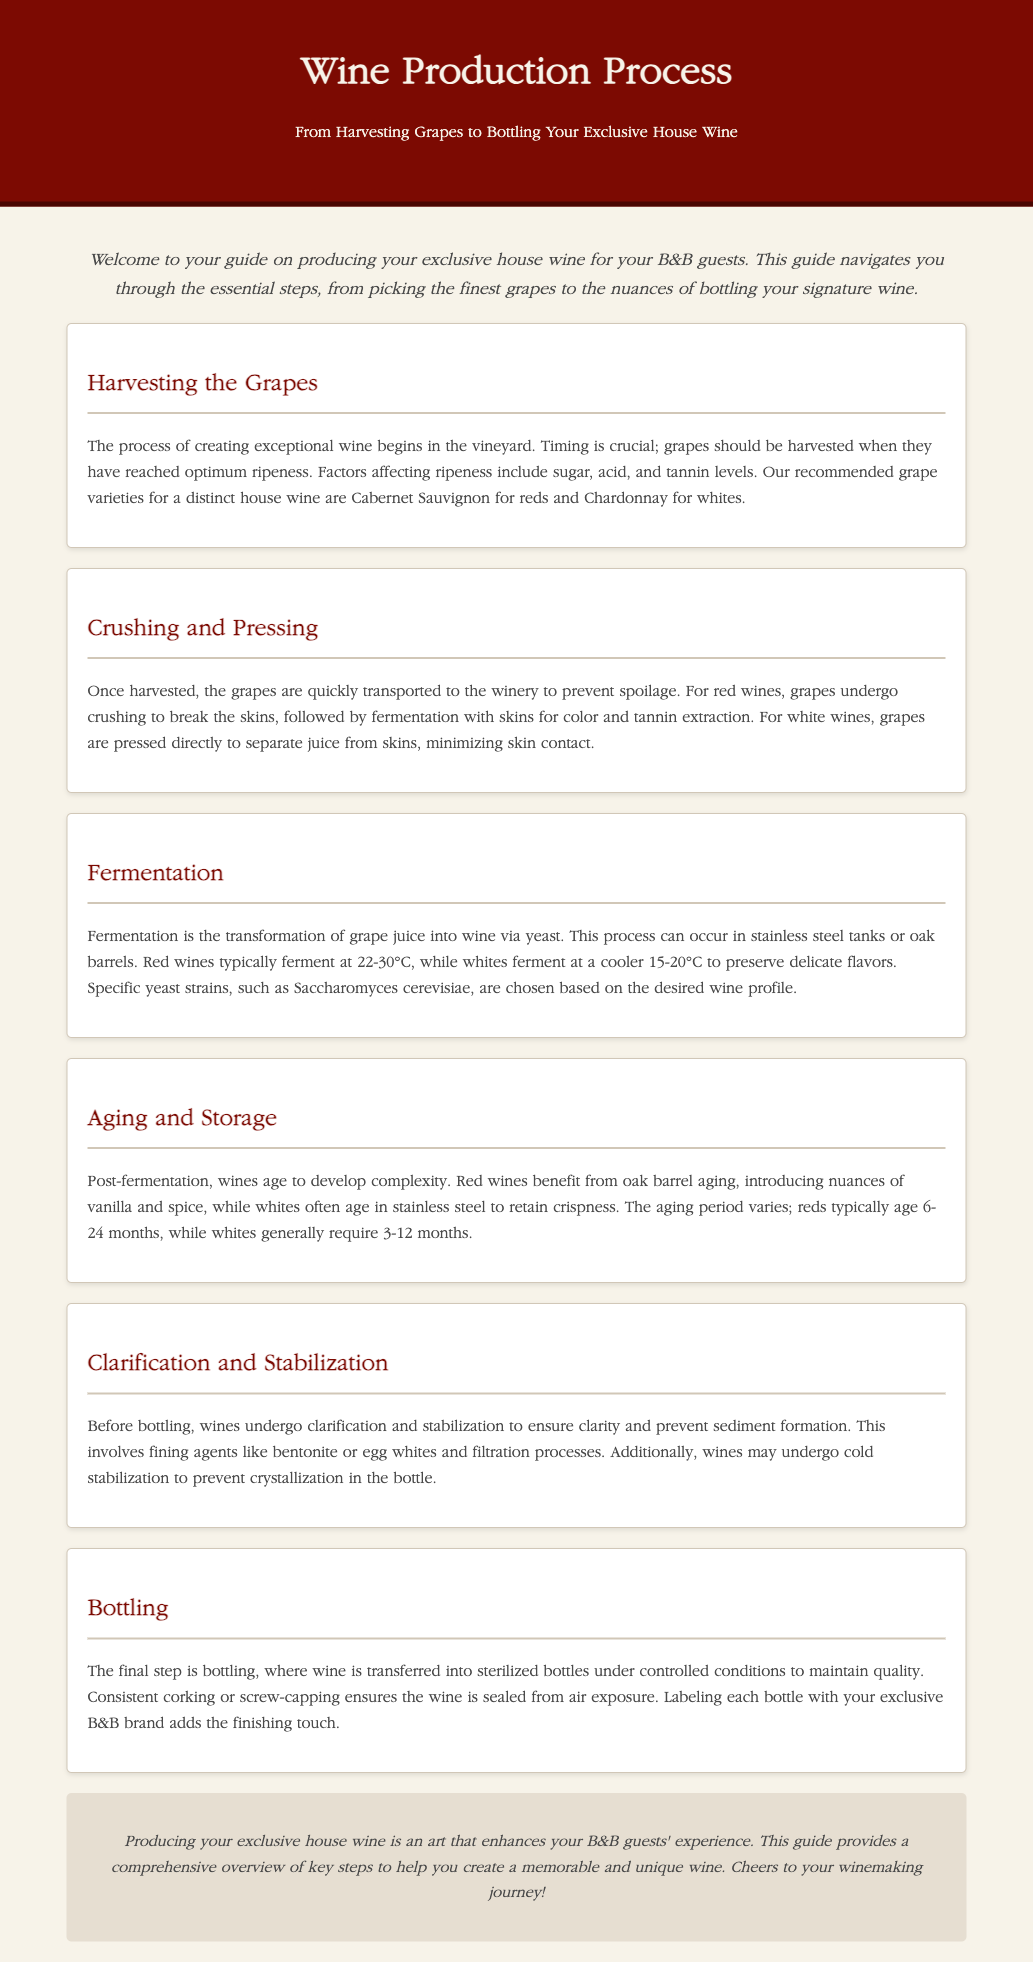What grape varieties are recommended for house wine? The document mentions Cabernet Sauvignon for reds and Chardonnay for whites as the recommended grape varieties.
Answer: Cabernet Sauvignon, Chardonnay What is the fermentation temperature range for red wines? The document specifies that red wines typically ferment at 22-30°C.
Answer: 22-30°C How long do red wines typically age? According to the document, red wines typically age for 6-24 months.
Answer: 6-24 months What process is used to clarify wines before bottling? The document indicates that clarification involves fining agents like bentonite or egg whites and filtration processes.
Answer: Fining agents, filtration What is the final step in the wine production process? The document states that the final step is bottling, where wine is transferred into sterilized bottles.
Answer: Bottling What is the purpose of aging wines? Aging wines is aimed at developing complexity, as highlighted in the aging section.
Answer: Develop complexity What type of barrel is used for aging red wines? The document notes that red wines benefit from oak barrel aging, introducing nuances of vanilla and spice.
Answer: Oak barrel What is essential for maintaining wine quality during bottling? The document emphasizes that transferring wine into sterilized bottles under controlled conditions is essential for quality.
Answer: Sterilized bottles What does the document conclude about producing house wine for B&B guests? The conclusion mentions that producing exclusive house wine enhances guests' experience.
Answer: Enhances experience 